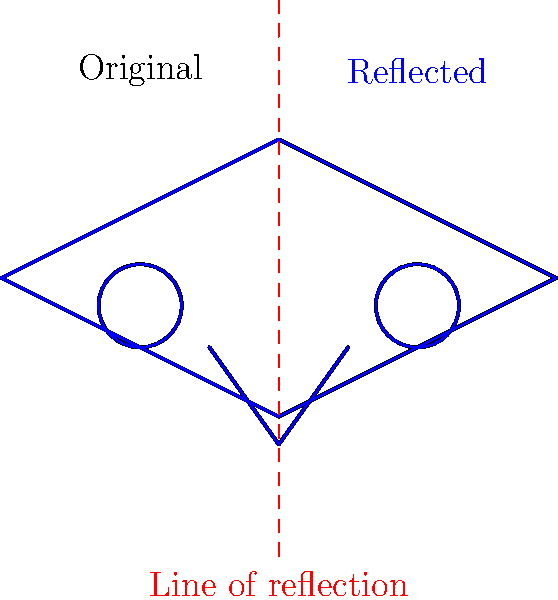In the abstract SCP-049 mask design shown above, a reflection transformation has been applied. If the original mask is represented by the function $f(x)$ and the reflected mask by $g(x)$, what is the relationship between $f(x)$ and $g(x)$ in terms of the line of reflection $x=2$? To understand the relationship between the original function $f(x)$ and the reflected function $g(x)$, let's follow these steps:

1. Observe that the line of reflection is vertical and passes through $x=2$.

2. For any point $(x,y)$ on the original mask, its reflection will be at $(4-x,y)$. This is because the distance from any point to the line of reflection is preserved in the reflection.

3. We can express this relationship mathematically:
   If $(x,y)$ is a point on $f(x)$, then $(4-x,y)$ is the corresponding point on $g(x)$.

4. In function notation, this means:
   $f(x) = g(4-x)$

5. Alternatively, we can express $g(x)$ in terms of $f(x)$:
   $g(x) = f(4-x)$

This equation tells us that to get any point on the reflected mask, we take the corresponding point on the original mask that is the same distance from the line of reflection, but on the opposite side.
Answer: $g(x) = f(4-x)$ 